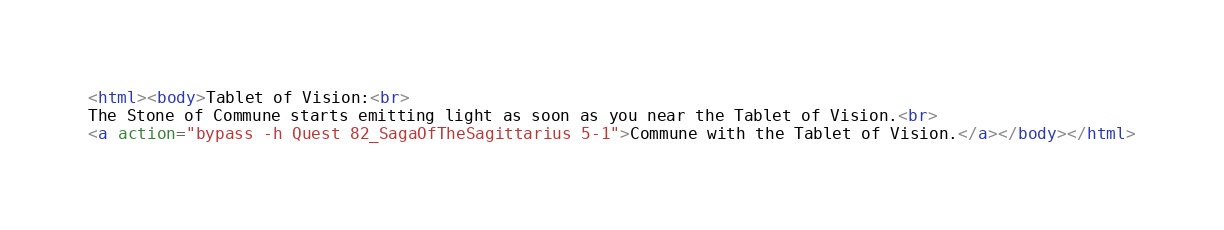Convert code to text. <code><loc_0><loc_0><loc_500><loc_500><_HTML_><html><body>Tablet of Vision:<br>
The Stone of Commune starts emitting light as soon as you near the Tablet of Vision.<br>
<a action="bypass -h Quest 82_SagaOfTheSagittarius 5-1">Commune with the Tablet of Vision.</a></body></html></code> 